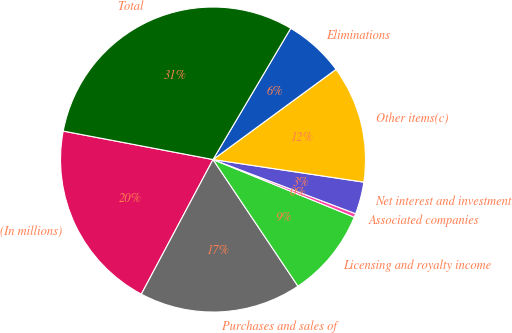Convert chart to OTSL. <chart><loc_0><loc_0><loc_500><loc_500><pie_chart><fcel>(In millions)<fcel>Purchases and sales of<fcel>Licensing and royalty income<fcel>Associated companies<fcel>Net interest and investment<fcel>Other items(c)<fcel>Eliminations<fcel>Total<nl><fcel>20.2%<fcel>17.19%<fcel>9.43%<fcel>0.39%<fcel>3.41%<fcel>12.44%<fcel>6.42%<fcel>30.52%<nl></chart> 